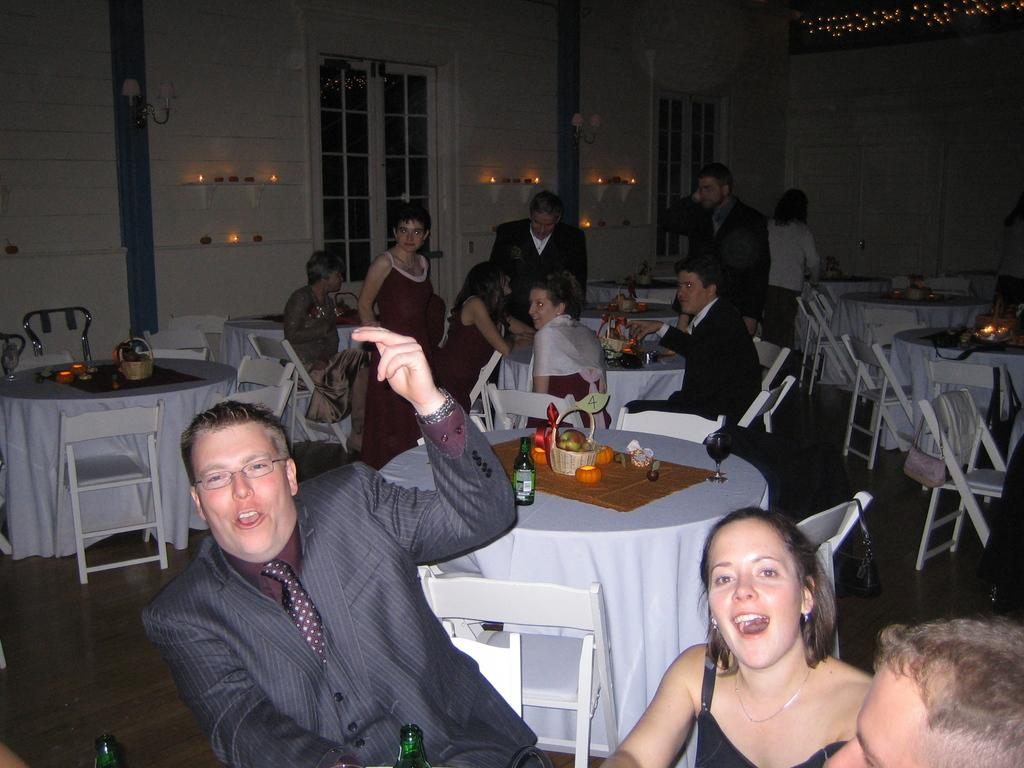What are the people in the image doing? The people in the image are sitting on chairs. Where are the chairs located in relation to the table? The chairs are near a table. What can be seen in the background of the image? There is a wall, a window, candles, and a light source in the background of the image. Can you tell me how fast the river is flowing in the image? There is no river present in the image; it features people sitting on chairs near a table with a background that includes a wall, a window, candles, and a light source. 